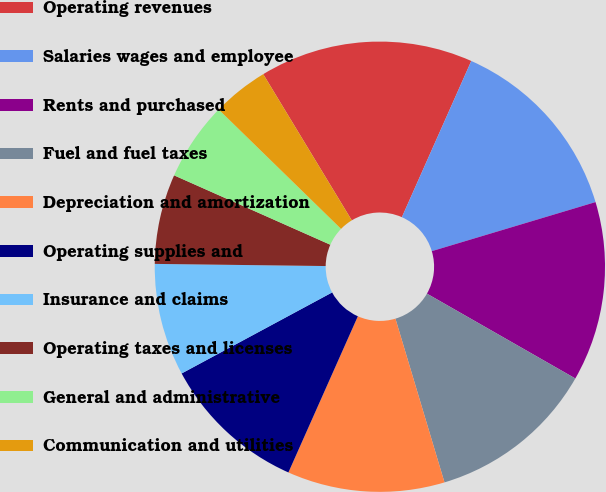Convert chart. <chart><loc_0><loc_0><loc_500><loc_500><pie_chart><fcel>Operating revenues<fcel>Salaries wages and employee<fcel>Rents and purchased<fcel>Fuel and fuel taxes<fcel>Depreciation and amortization<fcel>Operating supplies and<fcel>Insurance and claims<fcel>Operating taxes and licenses<fcel>General and administrative<fcel>Communication and utilities<nl><fcel>15.32%<fcel>13.71%<fcel>12.9%<fcel>12.1%<fcel>11.29%<fcel>10.48%<fcel>8.06%<fcel>6.45%<fcel>5.65%<fcel>4.03%<nl></chart> 